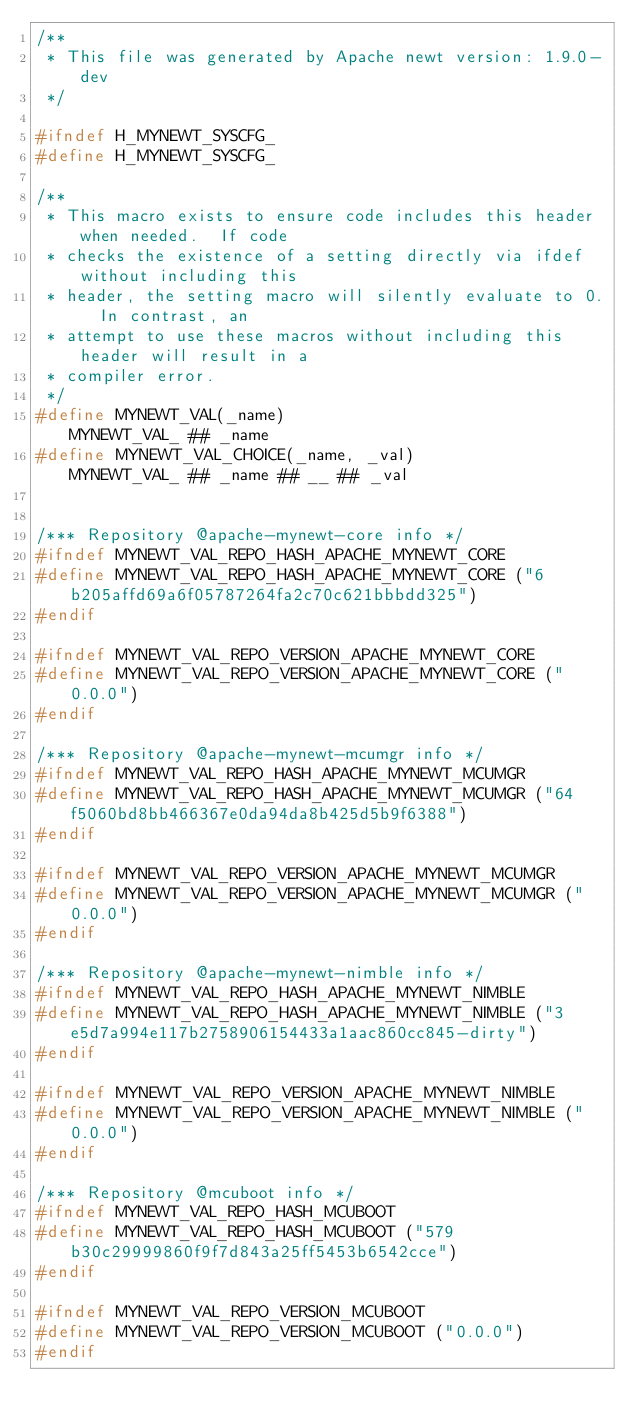<code> <loc_0><loc_0><loc_500><loc_500><_C_>/**
 * This file was generated by Apache newt version: 1.9.0-dev
 */

#ifndef H_MYNEWT_SYSCFG_
#define H_MYNEWT_SYSCFG_

/**
 * This macro exists to ensure code includes this header when needed.  If code
 * checks the existence of a setting directly via ifdef without including this
 * header, the setting macro will silently evaluate to 0.  In contrast, an
 * attempt to use these macros without including this header will result in a
 * compiler error.
 */
#define MYNEWT_VAL(_name)                       MYNEWT_VAL_ ## _name
#define MYNEWT_VAL_CHOICE(_name, _val)          MYNEWT_VAL_ ## _name ## __ ## _val


/*** Repository @apache-mynewt-core info */
#ifndef MYNEWT_VAL_REPO_HASH_APACHE_MYNEWT_CORE
#define MYNEWT_VAL_REPO_HASH_APACHE_MYNEWT_CORE ("6b205affd69a6f05787264fa2c70c621bbbdd325")
#endif

#ifndef MYNEWT_VAL_REPO_VERSION_APACHE_MYNEWT_CORE
#define MYNEWT_VAL_REPO_VERSION_APACHE_MYNEWT_CORE ("0.0.0")
#endif

/*** Repository @apache-mynewt-mcumgr info */
#ifndef MYNEWT_VAL_REPO_HASH_APACHE_MYNEWT_MCUMGR
#define MYNEWT_VAL_REPO_HASH_APACHE_MYNEWT_MCUMGR ("64f5060bd8bb466367e0da94da8b425d5b9f6388")
#endif

#ifndef MYNEWT_VAL_REPO_VERSION_APACHE_MYNEWT_MCUMGR
#define MYNEWT_VAL_REPO_VERSION_APACHE_MYNEWT_MCUMGR ("0.0.0")
#endif

/*** Repository @apache-mynewt-nimble info */
#ifndef MYNEWT_VAL_REPO_HASH_APACHE_MYNEWT_NIMBLE
#define MYNEWT_VAL_REPO_HASH_APACHE_MYNEWT_NIMBLE ("3e5d7a994e117b2758906154433a1aac860cc845-dirty")
#endif

#ifndef MYNEWT_VAL_REPO_VERSION_APACHE_MYNEWT_NIMBLE
#define MYNEWT_VAL_REPO_VERSION_APACHE_MYNEWT_NIMBLE ("0.0.0")
#endif

/*** Repository @mcuboot info */
#ifndef MYNEWT_VAL_REPO_HASH_MCUBOOT
#define MYNEWT_VAL_REPO_HASH_MCUBOOT ("579b30c29999860f9f7d843a25ff5453b6542cce")
#endif

#ifndef MYNEWT_VAL_REPO_VERSION_MCUBOOT
#define MYNEWT_VAL_REPO_VERSION_MCUBOOT ("0.0.0")
#endif


</code> 